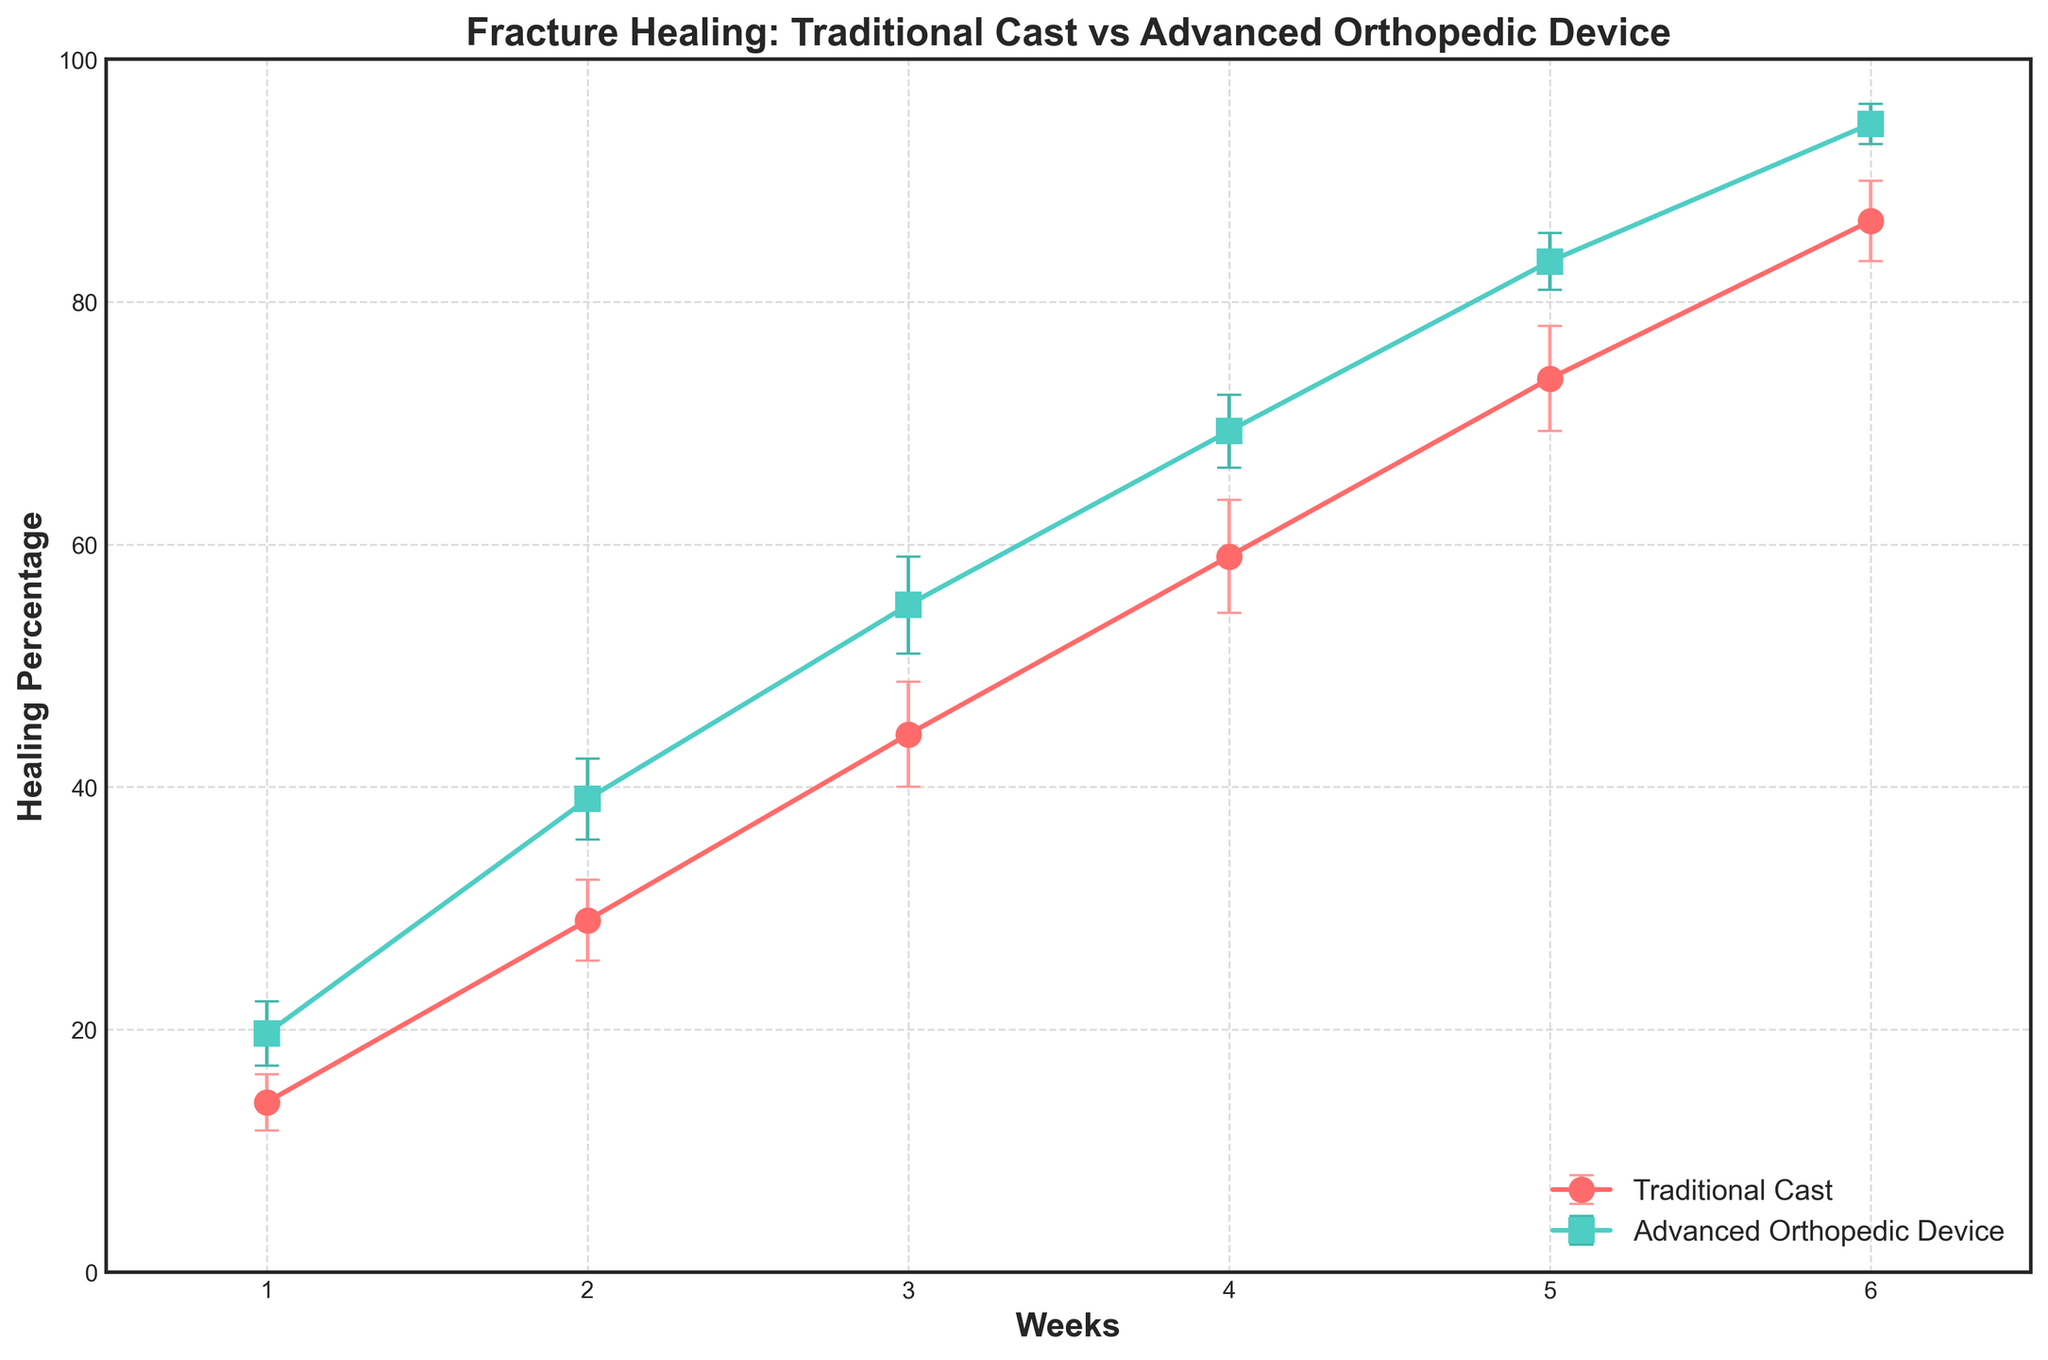How many weeks are plotted on the x-axis? The x-axis plots the number of weeks, ranging from 1 to 6. We can visually see six distinct ticks, each representing a week.
Answer: 6 What are the colors used to represent the traditional cast and advanced orthopedic device? The traditional cast is represented by red color, and the advanced orthopedic device is represented by green color. This can be determined by looking at the colors of the lines and markers in the legend.
Answer: Red for traditional cast and green for advanced orthopedic device Which device shows a higher mean healing percentage at week 3? By observing the y-values of the lines at week 3, the traditional cast has a mean healing percentage of 44.5%, while the advanced orthopedic device shows a mean healing percentage of 55%.
Answer: Advanced orthopedic device What is the difference in mean healing percentage between the two devices at week 6? At week 6, the traditional cast has a mean healing percentage of 86%, and the advanced orthopedic device has a mean healing percentage of 94.5%. The difference is calculated as 94.5% - 86% = 8.5%.
Answer: 8.5% How much does the mean healing percentage increase from week 1 to week 6 for the traditional cast? The mean healing percentage for the traditional cast at week 1 is 14%, and at week 6 is 86%. The increase can be calculated as 86% - 14% = 72%.
Answer: 72% Which week's data has the largest error bars for the traditional cast? By visually inspecting the length of the error bars, week 4 shows the largest error bars for the traditional cast, signifying the highest uncertainty.
Answer: Week 4 What is the average mean healing percentage of the advanced orthopedic device across all weeks? To calculate the average mean healing percentage, sum the mean percentages for all weeks [19.75, 38.25, 55.75, 69.5, 83.75, 94.5] and divide by 6. The average is (19.75 + 38.25 + 55.75 + 69.5 + 83.75 + 94.5) / 6 = 60.91%.
Answer: 60.91% Do the error bars for the advanced orthopedic device overlap those of the traditional cast at any point? By closely examining the error bars for both devices at each week, there is minimal overlap, indicating that the performance differences are distinguishable across the healing weeks.
Answer: Minimal overlap Which device generally shows less variability (smaller error bars) throughout the study period? The advanced orthopedic device generally shows smaller error bars compared to the traditional cast, indicating less variability and more consistent performance.
Answer: Advanced orthopedic device On average, how much does the healing percentage increase per week for the advanced orthopedic device? Calculate the average weekly increase by finding the difference in healing percentage between consecutive weeks: [(38.25-19.75), (55.75-38.25), (69.5-55.75), (83.75-69.5), (94.5-83.75)], which are [18.5, 17.5, 13.75, 14.25, 10.75]. Summing these differences: 18.5 + 17.5 + 13.75 + 14.25 + 10.75 = 74.75, then dividing by 5 weeks gives 74.75/5 = 14.95%.
Answer: 14.95% per week 